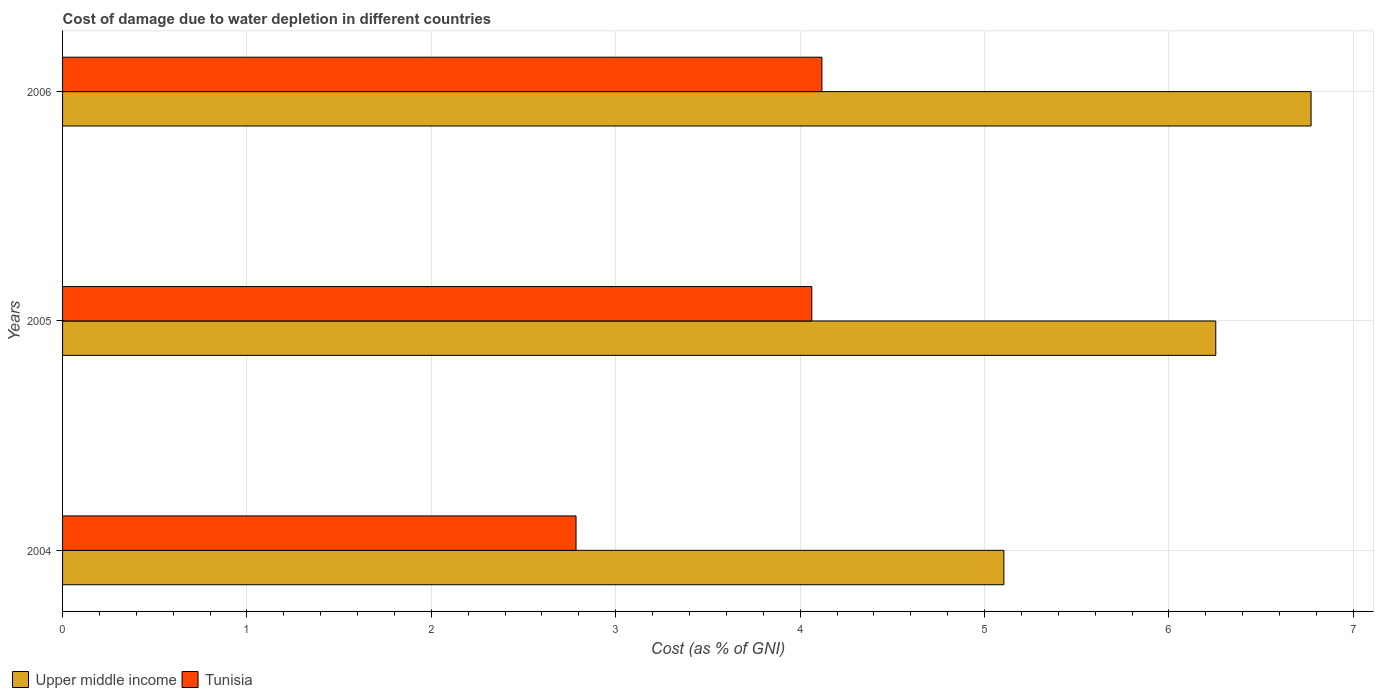How many different coloured bars are there?
Keep it short and to the point. 2. How many groups of bars are there?
Keep it short and to the point. 3. Are the number of bars on each tick of the Y-axis equal?
Provide a succinct answer. Yes. How many bars are there on the 1st tick from the bottom?
Make the answer very short. 2. What is the cost of damage caused due to water depletion in Upper middle income in 2006?
Ensure brevity in your answer.  6.77. Across all years, what is the maximum cost of damage caused due to water depletion in Upper middle income?
Keep it short and to the point. 6.77. Across all years, what is the minimum cost of damage caused due to water depletion in Tunisia?
Ensure brevity in your answer.  2.78. What is the total cost of damage caused due to water depletion in Tunisia in the graph?
Ensure brevity in your answer.  10.97. What is the difference between the cost of damage caused due to water depletion in Tunisia in 2005 and that in 2006?
Provide a short and direct response. -0.05. What is the difference between the cost of damage caused due to water depletion in Upper middle income in 2004 and the cost of damage caused due to water depletion in Tunisia in 2005?
Your answer should be compact. 1.04. What is the average cost of damage caused due to water depletion in Tunisia per year?
Provide a succinct answer. 3.66. In the year 2004, what is the difference between the cost of damage caused due to water depletion in Tunisia and cost of damage caused due to water depletion in Upper middle income?
Provide a short and direct response. -2.32. In how many years, is the cost of damage caused due to water depletion in Upper middle income greater than 0.8 %?
Offer a terse response. 3. What is the ratio of the cost of damage caused due to water depletion in Tunisia in 2004 to that in 2006?
Keep it short and to the point. 0.68. What is the difference between the highest and the second highest cost of damage caused due to water depletion in Upper middle income?
Keep it short and to the point. 0.52. What is the difference between the highest and the lowest cost of damage caused due to water depletion in Tunisia?
Provide a succinct answer. 1.33. What does the 1st bar from the top in 2005 represents?
Ensure brevity in your answer.  Tunisia. What does the 1st bar from the bottom in 2006 represents?
Provide a short and direct response. Upper middle income. Are all the bars in the graph horizontal?
Your answer should be compact. Yes. How many years are there in the graph?
Give a very brief answer. 3. What is the difference between two consecutive major ticks on the X-axis?
Offer a very short reply. 1. Are the values on the major ticks of X-axis written in scientific E-notation?
Provide a succinct answer. No. Does the graph contain any zero values?
Offer a very short reply. No. Does the graph contain grids?
Offer a terse response. Yes. Where does the legend appear in the graph?
Provide a succinct answer. Bottom left. How many legend labels are there?
Your response must be concise. 2. What is the title of the graph?
Offer a terse response. Cost of damage due to water depletion in different countries. Does "India" appear as one of the legend labels in the graph?
Offer a very short reply. No. What is the label or title of the X-axis?
Provide a short and direct response. Cost (as % of GNI). What is the Cost (as % of GNI) in Upper middle income in 2004?
Make the answer very short. 5.1. What is the Cost (as % of GNI) of Tunisia in 2004?
Give a very brief answer. 2.78. What is the Cost (as % of GNI) in Upper middle income in 2005?
Offer a terse response. 6.25. What is the Cost (as % of GNI) in Tunisia in 2005?
Make the answer very short. 4.06. What is the Cost (as % of GNI) in Upper middle income in 2006?
Give a very brief answer. 6.77. What is the Cost (as % of GNI) in Tunisia in 2006?
Ensure brevity in your answer.  4.12. Across all years, what is the maximum Cost (as % of GNI) in Upper middle income?
Keep it short and to the point. 6.77. Across all years, what is the maximum Cost (as % of GNI) in Tunisia?
Ensure brevity in your answer.  4.12. Across all years, what is the minimum Cost (as % of GNI) in Upper middle income?
Your response must be concise. 5.1. Across all years, what is the minimum Cost (as % of GNI) of Tunisia?
Your answer should be very brief. 2.78. What is the total Cost (as % of GNI) in Upper middle income in the graph?
Offer a very short reply. 18.13. What is the total Cost (as % of GNI) of Tunisia in the graph?
Keep it short and to the point. 10.97. What is the difference between the Cost (as % of GNI) in Upper middle income in 2004 and that in 2005?
Your answer should be compact. -1.15. What is the difference between the Cost (as % of GNI) in Tunisia in 2004 and that in 2005?
Give a very brief answer. -1.28. What is the difference between the Cost (as % of GNI) in Upper middle income in 2004 and that in 2006?
Provide a succinct answer. -1.67. What is the difference between the Cost (as % of GNI) of Tunisia in 2004 and that in 2006?
Your answer should be compact. -1.33. What is the difference between the Cost (as % of GNI) in Upper middle income in 2005 and that in 2006?
Provide a succinct answer. -0.52. What is the difference between the Cost (as % of GNI) of Tunisia in 2005 and that in 2006?
Provide a short and direct response. -0.05. What is the difference between the Cost (as % of GNI) in Upper middle income in 2004 and the Cost (as % of GNI) in Tunisia in 2005?
Your answer should be very brief. 1.04. What is the difference between the Cost (as % of GNI) in Upper middle income in 2005 and the Cost (as % of GNI) in Tunisia in 2006?
Give a very brief answer. 2.14. What is the average Cost (as % of GNI) in Upper middle income per year?
Offer a very short reply. 6.04. What is the average Cost (as % of GNI) of Tunisia per year?
Keep it short and to the point. 3.66. In the year 2004, what is the difference between the Cost (as % of GNI) of Upper middle income and Cost (as % of GNI) of Tunisia?
Ensure brevity in your answer.  2.32. In the year 2005, what is the difference between the Cost (as % of GNI) of Upper middle income and Cost (as % of GNI) of Tunisia?
Your answer should be very brief. 2.19. In the year 2006, what is the difference between the Cost (as % of GNI) in Upper middle income and Cost (as % of GNI) in Tunisia?
Offer a very short reply. 2.65. What is the ratio of the Cost (as % of GNI) in Upper middle income in 2004 to that in 2005?
Make the answer very short. 0.82. What is the ratio of the Cost (as % of GNI) in Tunisia in 2004 to that in 2005?
Make the answer very short. 0.69. What is the ratio of the Cost (as % of GNI) of Upper middle income in 2004 to that in 2006?
Your response must be concise. 0.75. What is the ratio of the Cost (as % of GNI) of Tunisia in 2004 to that in 2006?
Offer a very short reply. 0.68. What is the ratio of the Cost (as % of GNI) of Upper middle income in 2005 to that in 2006?
Provide a succinct answer. 0.92. What is the ratio of the Cost (as % of GNI) of Tunisia in 2005 to that in 2006?
Provide a short and direct response. 0.99. What is the difference between the highest and the second highest Cost (as % of GNI) in Upper middle income?
Your answer should be compact. 0.52. What is the difference between the highest and the second highest Cost (as % of GNI) in Tunisia?
Make the answer very short. 0.05. What is the difference between the highest and the lowest Cost (as % of GNI) of Upper middle income?
Give a very brief answer. 1.67. What is the difference between the highest and the lowest Cost (as % of GNI) in Tunisia?
Offer a very short reply. 1.33. 